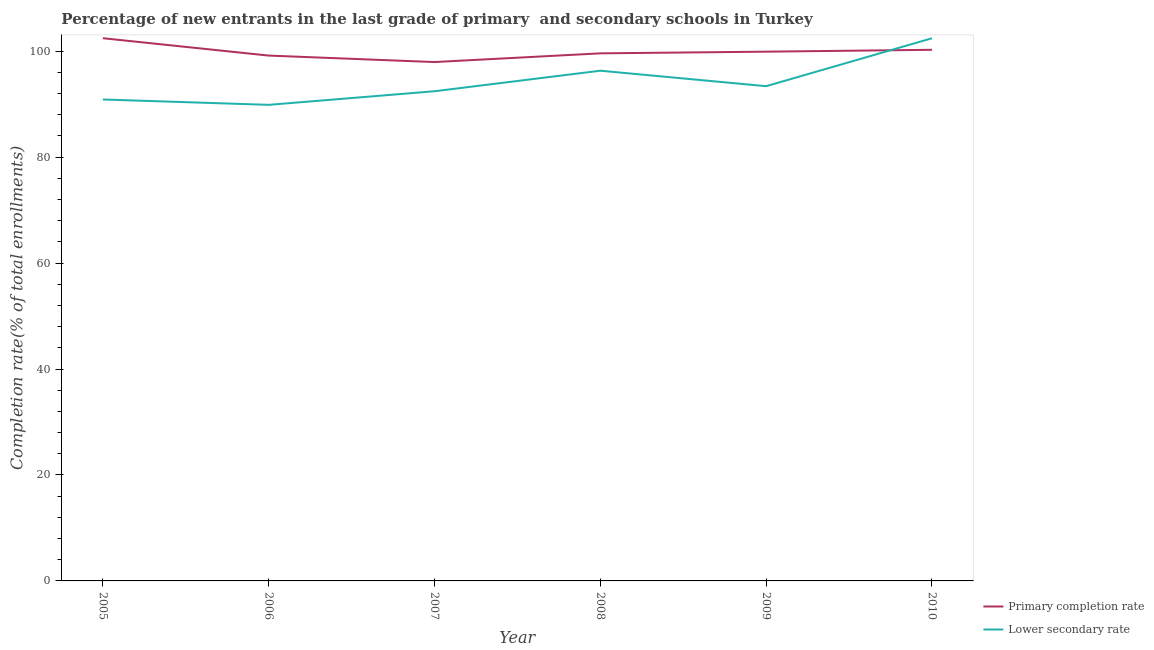Does the line corresponding to completion rate in secondary schools intersect with the line corresponding to completion rate in primary schools?
Ensure brevity in your answer.  Yes. Is the number of lines equal to the number of legend labels?
Give a very brief answer. Yes. What is the completion rate in primary schools in 2008?
Your answer should be very brief. 99.58. Across all years, what is the maximum completion rate in primary schools?
Ensure brevity in your answer.  102.44. Across all years, what is the minimum completion rate in secondary schools?
Your response must be concise. 89.86. In which year was the completion rate in primary schools minimum?
Keep it short and to the point. 2007. What is the total completion rate in secondary schools in the graph?
Offer a very short reply. 565.27. What is the difference between the completion rate in secondary schools in 2006 and that in 2010?
Keep it short and to the point. -12.57. What is the difference between the completion rate in secondary schools in 2009 and the completion rate in primary schools in 2006?
Your answer should be compact. -5.78. What is the average completion rate in secondary schools per year?
Provide a short and direct response. 94.21. In the year 2006, what is the difference between the completion rate in secondary schools and completion rate in primary schools?
Make the answer very short. -9.3. What is the ratio of the completion rate in primary schools in 2008 to that in 2010?
Provide a short and direct response. 0.99. Is the completion rate in secondary schools in 2007 less than that in 2009?
Give a very brief answer. Yes. What is the difference between the highest and the second highest completion rate in primary schools?
Offer a terse response. 2.19. What is the difference between the highest and the lowest completion rate in primary schools?
Ensure brevity in your answer.  4.5. In how many years, is the completion rate in secondary schools greater than the average completion rate in secondary schools taken over all years?
Offer a terse response. 2. Where does the legend appear in the graph?
Your answer should be very brief. Bottom right. How are the legend labels stacked?
Ensure brevity in your answer.  Vertical. What is the title of the graph?
Provide a short and direct response. Percentage of new entrants in the last grade of primary  and secondary schools in Turkey. Does "From human activities" appear as one of the legend labels in the graph?
Offer a very short reply. No. What is the label or title of the X-axis?
Your response must be concise. Year. What is the label or title of the Y-axis?
Offer a very short reply. Completion rate(% of total enrollments). What is the Completion rate(% of total enrollments) in Primary completion rate in 2005?
Provide a succinct answer. 102.44. What is the Completion rate(% of total enrollments) of Lower secondary rate in 2005?
Ensure brevity in your answer.  90.87. What is the Completion rate(% of total enrollments) in Primary completion rate in 2006?
Your response must be concise. 99.16. What is the Completion rate(% of total enrollments) of Lower secondary rate in 2006?
Make the answer very short. 89.86. What is the Completion rate(% of total enrollments) of Primary completion rate in 2007?
Offer a very short reply. 97.94. What is the Completion rate(% of total enrollments) in Lower secondary rate in 2007?
Keep it short and to the point. 92.43. What is the Completion rate(% of total enrollments) of Primary completion rate in 2008?
Offer a terse response. 99.58. What is the Completion rate(% of total enrollments) in Lower secondary rate in 2008?
Your response must be concise. 96.3. What is the Completion rate(% of total enrollments) of Primary completion rate in 2009?
Your answer should be very brief. 99.89. What is the Completion rate(% of total enrollments) in Lower secondary rate in 2009?
Ensure brevity in your answer.  93.38. What is the Completion rate(% of total enrollments) of Primary completion rate in 2010?
Provide a short and direct response. 100.25. What is the Completion rate(% of total enrollments) in Lower secondary rate in 2010?
Give a very brief answer. 102.43. Across all years, what is the maximum Completion rate(% of total enrollments) in Primary completion rate?
Offer a terse response. 102.44. Across all years, what is the maximum Completion rate(% of total enrollments) in Lower secondary rate?
Provide a succinct answer. 102.43. Across all years, what is the minimum Completion rate(% of total enrollments) of Primary completion rate?
Offer a terse response. 97.94. Across all years, what is the minimum Completion rate(% of total enrollments) in Lower secondary rate?
Give a very brief answer. 89.86. What is the total Completion rate(% of total enrollments) in Primary completion rate in the graph?
Provide a short and direct response. 599.26. What is the total Completion rate(% of total enrollments) in Lower secondary rate in the graph?
Your answer should be compact. 565.27. What is the difference between the Completion rate(% of total enrollments) in Primary completion rate in 2005 and that in 2006?
Make the answer very short. 3.28. What is the difference between the Completion rate(% of total enrollments) in Lower secondary rate in 2005 and that in 2006?
Provide a succinct answer. 1.01. What is the difference between the Completion rate(% of total enrollments) of Primary completion rate in 2005 and that in 2007?
Provide a succinct answer. 4.5. What is the difference between the Completion rate(% of total enrollments) of Lower secondary rate in 2005 and that in 2007?
Offer a terse response. -1.56. What is the difference between the Completion rate(% of total enrollments) in Primary completion rate in 2005 and that in 2008?
Your response must be concise. 2.86. What is the difference between the Completion rate(% of total enrollments) in Lower secondary rate in 2005 and that in 2008?
Provide a succinct answer. -5.43. What is the difference between the Completion rate(% of total enrollments) in Primary completion rate in 2005 and that in 2009?
Provide a short and direct response. 2.54. What is the difference between the Completion rate(% of total enrollments) of Lower secondary rate in 2005 and that in 2009?
Keep it short and to the point. -2.51. What is the difference between the Completion rate(% of total enrollments) of Primary completion rate in 2005 and that in 2010?
Keep it short and to the point. 2.19. What is the difference between the Completion rate(% of total enrollments) in Lower secondary rate in 2005 and that in 2010?
Offer a terse response. -11.56. What is the difference between the Completion rate(% of total enrollments) in Primary completion rate in 2006 and that in 2007?
Your response must be concise. 1.22. What is the difference between the Completion rate(% of total enrollments) of Lower secondary rate in 2006 and that in 2007?
Make the answer very short. -2.57. What is the difference between the Completion rate(% of total enrollments) of Primary completion rate in 2006 and that in 2008?
Make the answer very short. -0.42. What is the difference between the Completion rate(% of total enrollments) of Lower secondary rate in 2006 and that in 2008?
Give a very brief answer. -6.44. What is the difference between the Completion rate(% of total enrollments) of Primary completion rate in 2006 and that in 2009?
Make the answer very short. -0.74. What is the difference between the Completion rate(% of total enrollments) in Lower secondary rate in 2006 and that in 2009?
Make the answer very short. -3.52. What is the difference between the Completion rate(% of total enrollments) in Primary completion rate in 2006 and that in 2010?
Offer a very short reply. -1.09. What is the difference between the Completion rate(% of total enrollments) in Lower secondary rate in 2006 and that in 2010?
Ensure brevity in your answer.  -12.57. What is the difference between the Completion rate(% of total enrollments) of Primary completion rate in 2007 and that in 2008?
Provide a short and direct response. -1.64. What is the difference between the Completion rate(% of total enrollments) of Lower secondary rate in 2007 and that in 2008?
Keep it short and to the point. -3.88. What is the difference between the Completion rate(% of total enrollments) in Primary completion rate in 2007 and that in 2009?
Offer a terse response. -1.96. What is the difference between the Completion rate(% of total enrollments) of Lower secondary rate in 2007 and that in 2009?
Offer a very short reply. -0.95. What is the difference between the Completion rate(% of total enrollments) of Primary completion rate in 2007 and that in 2010?
Provide a succinct answer. -2.31. What is the difference between the Completion rate(% of total enrollments) in Lower secondary rate in 2007 and that in 2010?
Provide a short and direct response. -10. What is the difference between the Completion rate(% of total enrollments) of Primary completion rate in 2008 and that in 2009?
Make the answer very short. -0.32. What is the difference between the Completion rate(% of total enrollments) of Lower secondary rate in 2008 and that in 2009?
Your answer should be compact. 2.92. What is the difference between the Completion rate(% of total enrollments) in Primary completion rate in 2008 and that in 2010?
Ensure brevity in your answer.  -0.67. What is the difference between the Completion rate(% of total enrollments) in Lower secondary rate in 2008 and that in 2010?
Offer a terse response. -6.12. What is the difference between the Completion rate(% of total enrollments) in Primary completion rate in 2009 and that in 2010?
Keep it short and to the point. -0.35. What is the difference between the Completion rate(% of total enrollments) of Lower secondary rate in 2009 and that in 2010?
Keep it short and to the point. -9.05. What is the difference between the Completion rate(% of total enrollments) in Primary completion rate in 2005 and the Completion rate(% of total enrollments) in Lower secondary rate in 2006?
Provide a short and direct response. 12.58. What is the difference between the Completion rate(% of total enrollments) in Primary completion rate in 2005 and the Completion rate(% of total enrollments) in Lower secondary rate in 2007?
Your answer should be very brief. 10.01. What is the difference between the Completion rate(% of total enrollments) of Primary completion rate in 2005 and the Completion rate(% of total enrollments) of Lower secondary rate in 2008?
Provide a succinct answer. 6.13. What is the difference between the Completion rate(% of total enrollments) in Primary completion rate in 2005 and the Completion rate(% of total enrollments) in Lower secondary rate in 2009?
Make the answer very short. 9.06. What is the difference between the Completion rate(% of total enrollments) of Primary completion rate in 2005 and the Completion rate(% of total enrollments) of Lower secondary rate in 2010?
Your answer should be compact. 0.01. What is the difference between the Completion rate(% of total enrollments) in Primary completion rate in 2006 and the Completion rate(% of total enrollments) in Lower secondary rate in 2007?
Provide a short and direct response. 6.73. What is the difference between the Completion rate(% of total enrollments) of Primary completion rate in 2006 and the Completion rate(% of total enrollments) of Lower secondary rate in 2008?
Your response must be concise. 2.86. What is the difference between the Completion rate(% of total enrollments) in Primary completion rate in 2006 and the Completion rate(% of total enrollments) in Lower secondary rate in 2009?
Give a very brief answer. 5.78. What is the difference between the Completion rate(% of total enrollments) of Primary completion rate in 2006 and the Completion rate(% of total enrollments) of Lower secondary rate in 2010?
Offer a very short reply. -3.27. What is the difference between the Completion rate(% of total enrollments) in Primary completion rate in 2007 and the Completion rate(% of total enrollments) in Lower secondary rate in 2008?
Your response must be concise. 1.64. What is the difference between the Completion rate(% of total enrollments) in Primary completion rate in 2007 and the Completion rate(% of total enrollments) in Lower secondary rate in 2009?
Make the answer very short. 4.56. What is the difference between the Completion rate(% of total enrollments) in Primary completion rate in 2007 and the Completion rate(% of total enrollments) in Lower secondary rate in 2010?
Keep it short and to the point. -4.49. What is the difference between the Completion rate(% of total enrollments) of Primary completion rate in 2008 and the Completion rate(% of total enrollments) of Lower secondary rate in 2009?
Keep it short and to the point. 6.2. What is the difference between the Completion rate(% of total enrollments) in Primary completion rate in 2008 and the Completion rate(% of total enrollments) in Lower secondary rate in 2010?
Provide a succinct answer. -2.85. What is the difference between the Completion rate(% of total enrollments) in Primary completion rate in 2009 and the Completion rate(% of total enrollments) in Lower secondary rate in 2010?
Offer a terse response. -2.53. What is the average Completion rate(% of total enrollments) of Primary completion rate per year?
Offer a terse response. 99.88. What is the average Completion rate(% of total enrollments) in Lower secondary rate per year?
Offer a very short reply. 94.21. In the year 2005, what is the difference between the Completion rate(% of total enrollments) of Primary completion rate and Completion rate(% of total enrollments) of Lower secondary rate?
Offer a terse response. 11.57. In the year 2006, what is the difference between the Completion rate(% of total enrollments) in Primary completion rate and Completion rate(% of total enrollments) in Lower secondary rate?
Give a very brief answer. 9.3. In the year 2007, what is the difference between the Completion rate(% of total enrollments) in Primary completion rate and Completion rate(% of total enrollments) in Lower secondary rate?
Make the answer very short. 5.51. In the year 2008, what is the difference between the Completion rate(% of total enrollments) of Primary completion rate and Completion rate(% of total enrollments) of Lower secondary rate?
Your response must be concise. 3.28. In the year 2009, what is the difference between the Completion rate(% of total enrollments) of Primary completion rate and Completion rate(% of total enrollments) of Lower secondary rate?
Give a very brief answer. 6.51. In the year 2010, what is the difference between the Completion rate(% of total enrollments) in Primary completion rate and Completion rate(% of total enrollments) in Lower secondary rate?
Give a very brief answer. -2.18. What is the ratio of the Completion rate(% of total enrollments) in Primary completion rate in 2005 to that in 2006?
Offer a terse response. 1.03. What is the ratio of the Completion rate(% of total enrollments) in Lower secondary rate in 2005 to that in 2006?
Your answer should be compact. 1.01. What is the ratio of the Completion rate(% of total enrollments) of Primary completion rate in 2005 to that in 2007?
Your response must be concise. 1.05. What is the ratio of the Completion rate(% of total enrollments) of Lower secondary rate in 2005 to that in 2007?
Provide a succinct answer. 0.98. What is the ratio of the Completion rate(% of total enrollments) in Primary completion rate in 2005 to that in 2008?
Keep it short and to the point. 1.03. What is the ratio of the Completion rate(% of total enrollments) of Lower secondary rate in 2005 to that in 2008?
Make the answer very short. 0.94. What is the ratio of the Completion rate(% of total enrollments) of Primary completion rate in 2005 to that in 2009?
Ensure brevity in your answer.  1.03. What is the ratio of the Completion rate(% of total enrollments) of Lower secondary rate in 2005 to that in 2009?
Your answer should be very brief. 0.97. What is the ratio of the Completion rate(% of total enrollments) in Primary completion rate in 2005 to that in 2010?
Keep it short and to the point. 1.02. What is the ratio of the Completion rate(% of total enrollments) of Lower secondary rate in 2005 to that in 2010?
Offer a terse response. 0.89. What is the ratio of the Completion rate(% of total enrollments) of Primary completion rate in 2006 to that in 2007?
Offer a terse response. 1.01. What is the ratio of the Completion rate(% of total enrollments) of Lower secondary rate in 2006 to that in 2007?
Your answer should be very brief. 0.97. What is the ratio of the Completion rate(% of total enrollments) of Lower secondary rate in 2006 to that in 2008?
Your answer should be very brief. 0.93. What is the ratio of the Completion rate(% of total enrollments) of Primary completion rate in 2006 to that in 2009?
Your answer should be compact. 0.99. What is the ratio of the Completion rate(% of total enrollments) of Lower secondary rate in 2006 to that in 2009?
Provide a succinct answer. 0.96. What is the ratio of the Completion rate(% of total enrollments) in Lower secondary rate in 2006 to that in 2010?
Provide a short and direct response. 0.88. What is the ratio of the Completion rate(% of total enrollments) of Primary completion rate in 2007 to that in 2008?
Provide a succinct answer. 0.98. What is the ratio of the Completion rate(% of total enrollments) of Lower secondary rate in 2007 to that in 2008?
Offer a terse response. 0.96. What is the ratio of the Completion rate(% of total enrollments) in Primary completion rate in 2007 to that in 2009?
Give a very brief answer. 0.98. What is the ratio of the Completion rate(% of total enrollments) of Lower secondary rate in 2007 to that in 2009?
Provide a succinct answer. 0.99. What is the ratio of the Completion rate(% of total enrollments) of Primary completion rate in 2007 to that in 2010?
Offer a terse response. 0.98. What is the ratio of the Completion rate(% of total enrollments) of Lower secondary rate in 2007 to that in 2010?
Make the answer very short. 0.9. What is the ratio of the Completion rate(% of total enrollments) of Lower secondary rate in 2008 to that in 2009?
Offer a very short reply. 1.03. What is the ratio of the Completion rate(% of total enrollments) of Primary completion rate in 2008 to that in 2010?
Give a very brief answer. 0.99. What is the ratio of the Completion rate(% of total enrollments) in Lower secondary rate in 2008 to that in 2010?
Give a very brief answer. 0.94. What is the ratio of the Completion rate(% of total enrollments) in Lower secondary rate in 2009 to that in 2010?
Provide a short and direct response. 0.91. What is the difference between the highest and the second highest Completion rate(% of total enrollments) in Primary completion rate?
Offer a very short reply. 2.19. What is the difference between the highest and the second highest Completion rate(% of total enrollments) in Lower secondary rate?
Provide a short and direct response. 6.12. What is the difference between the highest and the lowest Completion rate(% of total enrollments) of Primary completion rate?
Provide a succinct answer. 4.5. What is the difference between the highest and the lowest Completion rate(% of total enrollments) of Lower secondary rate?
Provide a succinct answer. 12.57. 